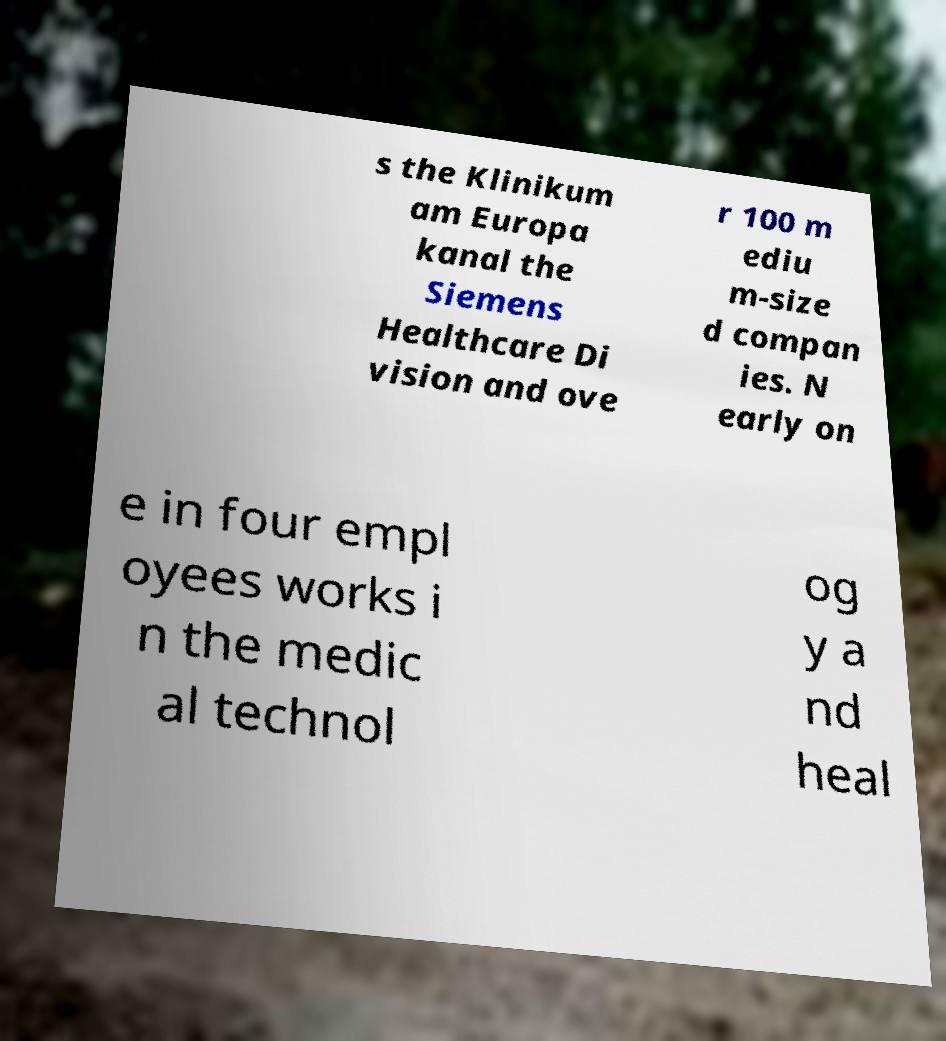Could you extract and type out the text from this image? s the Klinikum am Europa kanal the Siemens Healthcare Di vision and ove r 100 m ediu m-size d compan ies. N early on e in four empl oyees works i n the medic al technol og y a nd heal 